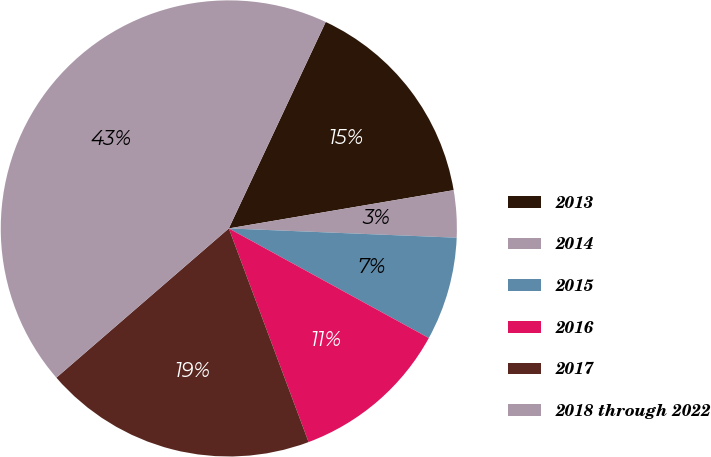<chart> <loc_0><loc_0><loc_500><loc_500><pie_chart><fcel>2013<fcel>2014<fcel>2015<fcel>2016<fcel>2017<fcel>2018 through 2022<nl><fcel>15.33%<fcel>3.33%<fcel>7.33%<fcel>11.33%<fcel>19.33%<fcel>43.33%<nl></chart> 